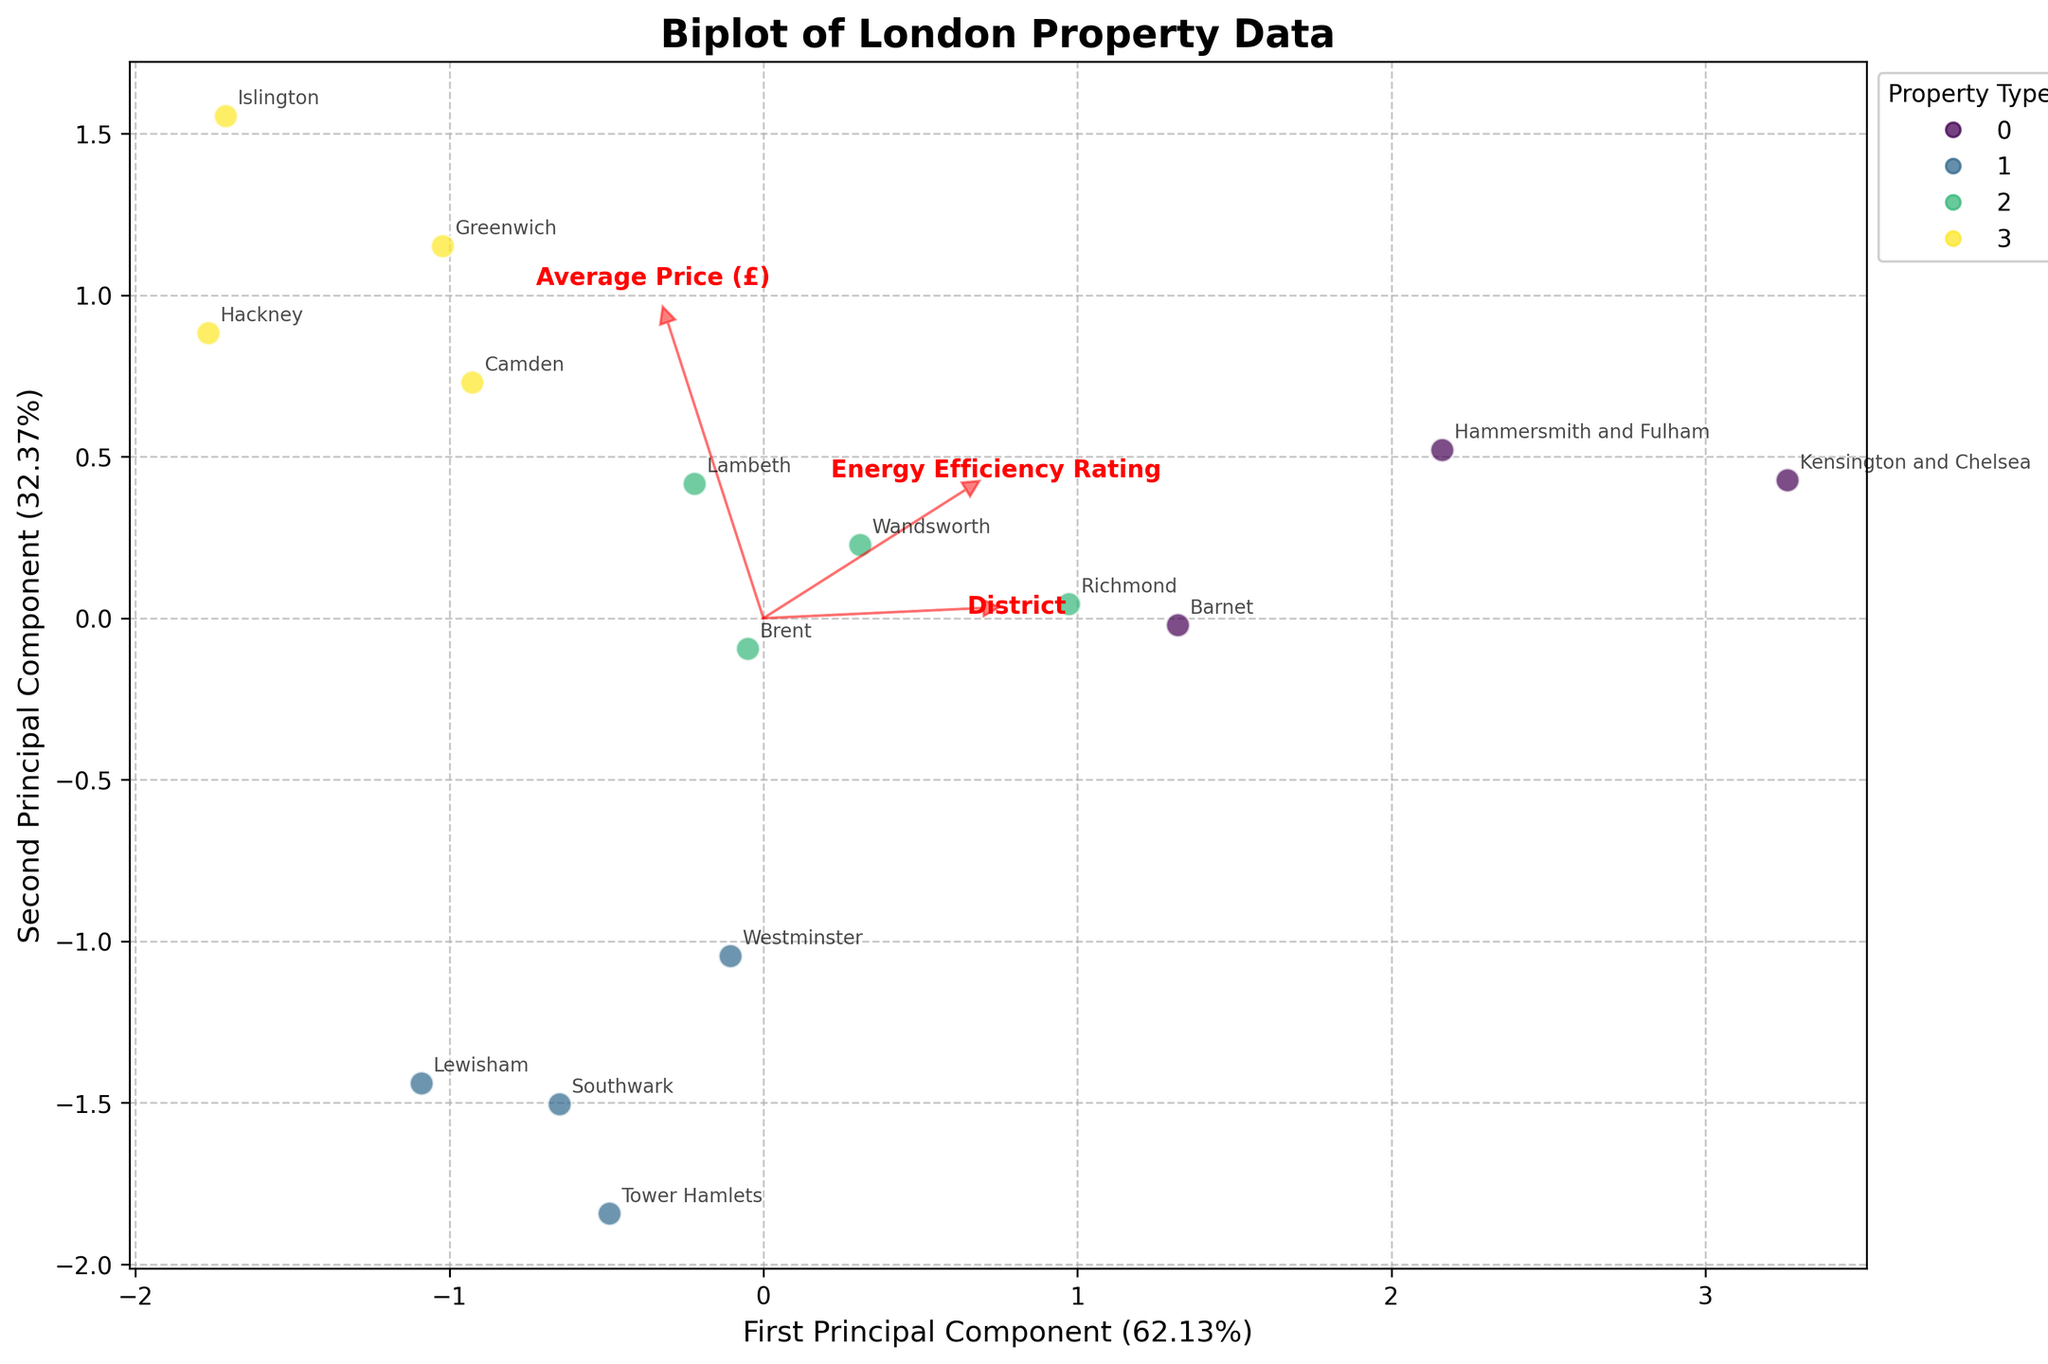What is the title of the plot? The title of the plot is usually found at the top of the figure, which summarizes the main content of the visualization.
Answer: Biplot of London Property Data How many different property types are displayed in the plot? Look at the legend on the right side of the plot to see the different colors representing each property type. Count the unique property types listed.
Answer: Four Which property type has the most points in the biplot? Observe the distribution of data points and their corresponding colors to determine which property type is most prevalent.
Answer: Flat What do the arrows in the biplot represent? The arrows represent the directions of the features (Energy Efficiency Rating, Average Price (£), Age (Years)) in the PCA-transformed space.
Answer: Features Which district appears to be closest to the origin of the biplot? Find the data point nearest to the (0,0) position of the biplot. Note the district label associated with that point.
Answer: Tower Hamlets How is 'Energy Efficiency Rating' oriented in the biplot? Look at the direction of the arrow labeled 'Energy Efficiency Rating' to determine its orientation relative to the principal components.
Answer: Towards the right and slightly upwards Which property type generally has higher 'Average Price (£)' as per the biplot? Identify the direction of the 'Average Price (£)' arrow and see which property type's data points are primarily along that direction.
Answer: Detached Is there a relationship between 'Age (Years)' and energy efficiency rating? Observe the relative orientation of the arrows representing 'Age (Years)' and 'Energy Efficiency Rating'. If they point in similar or opposite directions, there is a correlation.
Answer: Somewhat negative correlation Which feature contributes most to the first principal component? Analyze the lengths and directions of the arrows along the first principal component axis. The longest arrow in terms of projection indicates the most contributing feature.
Answer: Average Price (£) Are older properties more likely to be less energy-efficient based on the biplot? Compare the directions of the 'Age (Years)' and 'Energy Efficiency Rating' arrows. A negative correlation (arrows pointing in opposite directions) suggests older properties are less energy-efficient.
Answer: Yes 